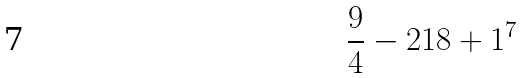Convert formula to latex. <formula><loc_0><loc_0><loc_500><loc_500>\frac { 9 } { 4 } - 2 1 8 + 1 ^ { 7 }</formula> 